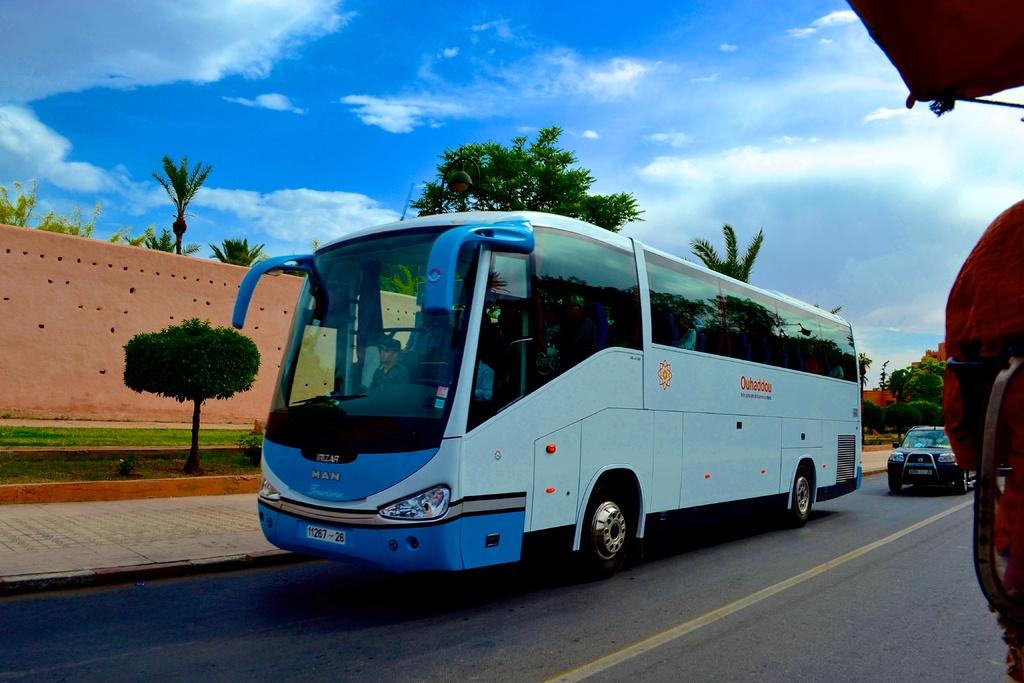What type of vehicle can be seen in the image? There is a bus in the image. Are there any other vehicles present in the image? Yes, there is a car in the image. Where are the bus and car located? Both the bus and car are on the road. What type of vegetation is visible in the image? There are plants, grass, and trees in the image. What is visible in the background of the image? The sky is visible in the background of the image, with clouds present. What is the setting of the image? The image features a road with a bus and car, surrounded by vegetation and a sky with clouds. What type of gate can be seen in the image? There is no gate present in the image. What substance is being transported by the bus in the image? The image does not provide any information about what the bus might be transporting, if anything. 